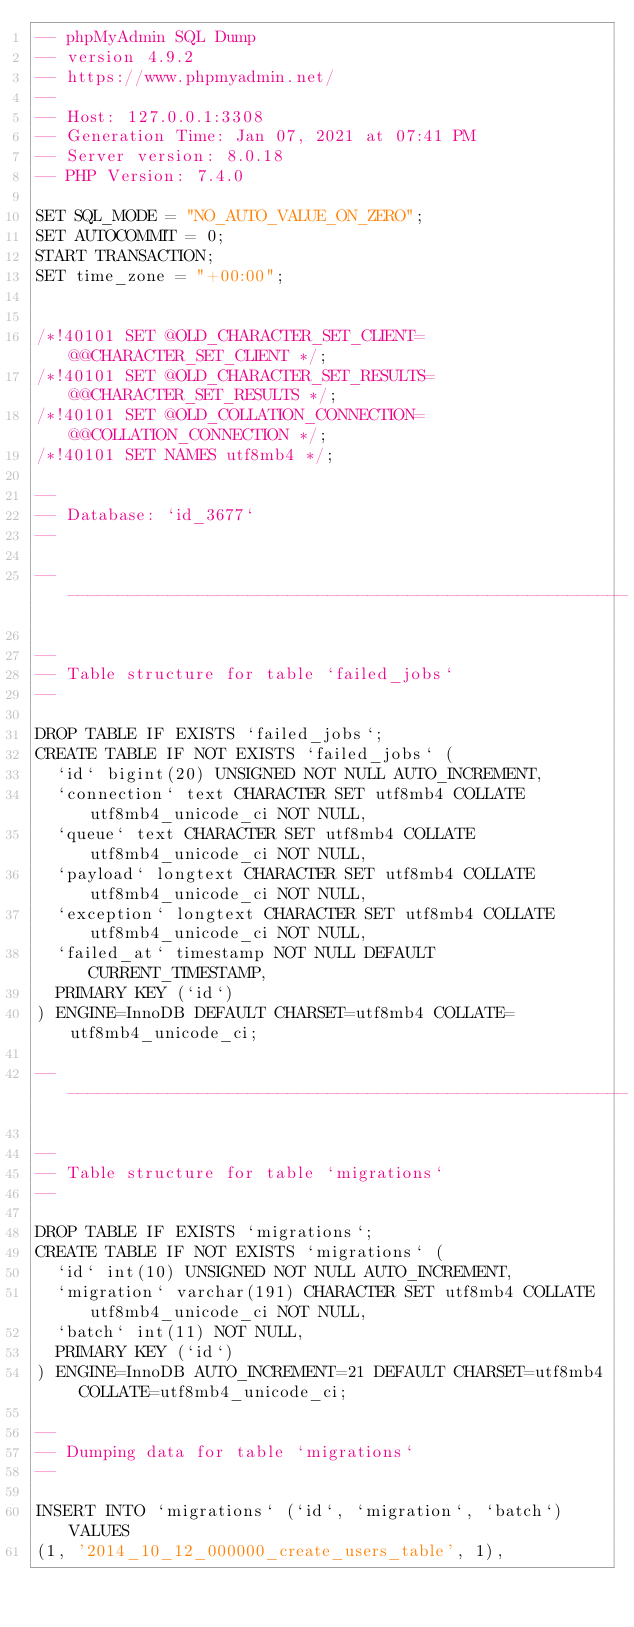<code> <loc_0><loc_0><loc_500><loc_500><_SQL_>-- phpMyAdmin SQL Dump
-- version 4.9.2
-- https://www.phpmyadmin.net/
--
-- Host: 127.0.0.1:3308
-- Generation Time: Jan 07, 2021 at 07:41 PM
-- Server version: 8.0.18
-- PHP Version: 7.4.0

SET SQL_MODE = "NO_AUTO_VALUE_ON_ZERO";
SET AUTOCOMMIT = 0;
START TRANSACTION;
SET time_zone = "+00:00";


/*!40101 SET @OLD_CHARACTER_SET_CLIENT=@@CHARACTER_SET_CLIENT */;
/*!40101 SET @OLD_CHARACTER_SET_RESULTS=@@CHARACTER_SET_RESULTS */;
/*!40101 SET @OLD_COLLATION_CONNECTION=@@COLLATION_CONNECTION */;
/*!40101 SET NAMES utf8mb4 */;

--
-- Database: `id_3677`
--

-- --------------------------------------------------------

--
-- Table structure for table `failed_jobs`
--

DROP TABLE IF EXISTS `failed_jobs`;
CREATE TABLE IF NOT EXISTS `failed_jobs` (
  `id` bigint(20) UNSIGNED NOT NULL AUTO_INCREMENT,
  `connection` text CHARACTER SET utf8mb4 COLLATE utf8mb4_unicode_ci NOT NULL,
  `queue` text CHARACTER SET utf8mb4 COLLATE utf8mb4_unicode_ci NOT NULL,
  `payload` longtext CHARACTER SET utf8mb4 COLLATE utf8mb4_unicode_ci NOT NULL,
  `exception` longtext CHARACTER SET utf8mb4 COLLATE utf8mb4_unicode_ci NOT NULL,
  `failed_at` timestamp NOT NULL DEFAULT CURRENT_TIMESTAMP,
  PRIMARY KEY (`id`)
) ENGINE=InnoDB DEFAULT CHARSET=utf8mb4 COLLATE=utf8mb4_unicode_ci;

-- --------------------------------------------------------

--
-- Table structure for table `migrations`
--

DROP TABLE IF EXISTS `migrations`;
CREATE TABLE IF NOT EXISTS `migrations` (
  `id` int(10) UNSIGNED NOT NULL AUTO_INCREMENT,
  `migration` varchar(191) CHARACTER SET utf8mb4 COLLATE utf8mb4_unicode_ci NOT NULL,
  `batch` int(11) NOT NULL,
  PRIMARY KEY (`id`)
) ENGINE=InnoDB AUTO_INCREMENT=21 DEFAULT CHARSET=utf8mb4 COLLATE=utf8mb4_unicode_ci;

--
-- Dumping data for table `migrations`
--

INSERT INTO `migrations` (`id`, `migration`, `batch`) VALUES
(1, '2014_10_12_000000_create_users_table', 1),</code> 